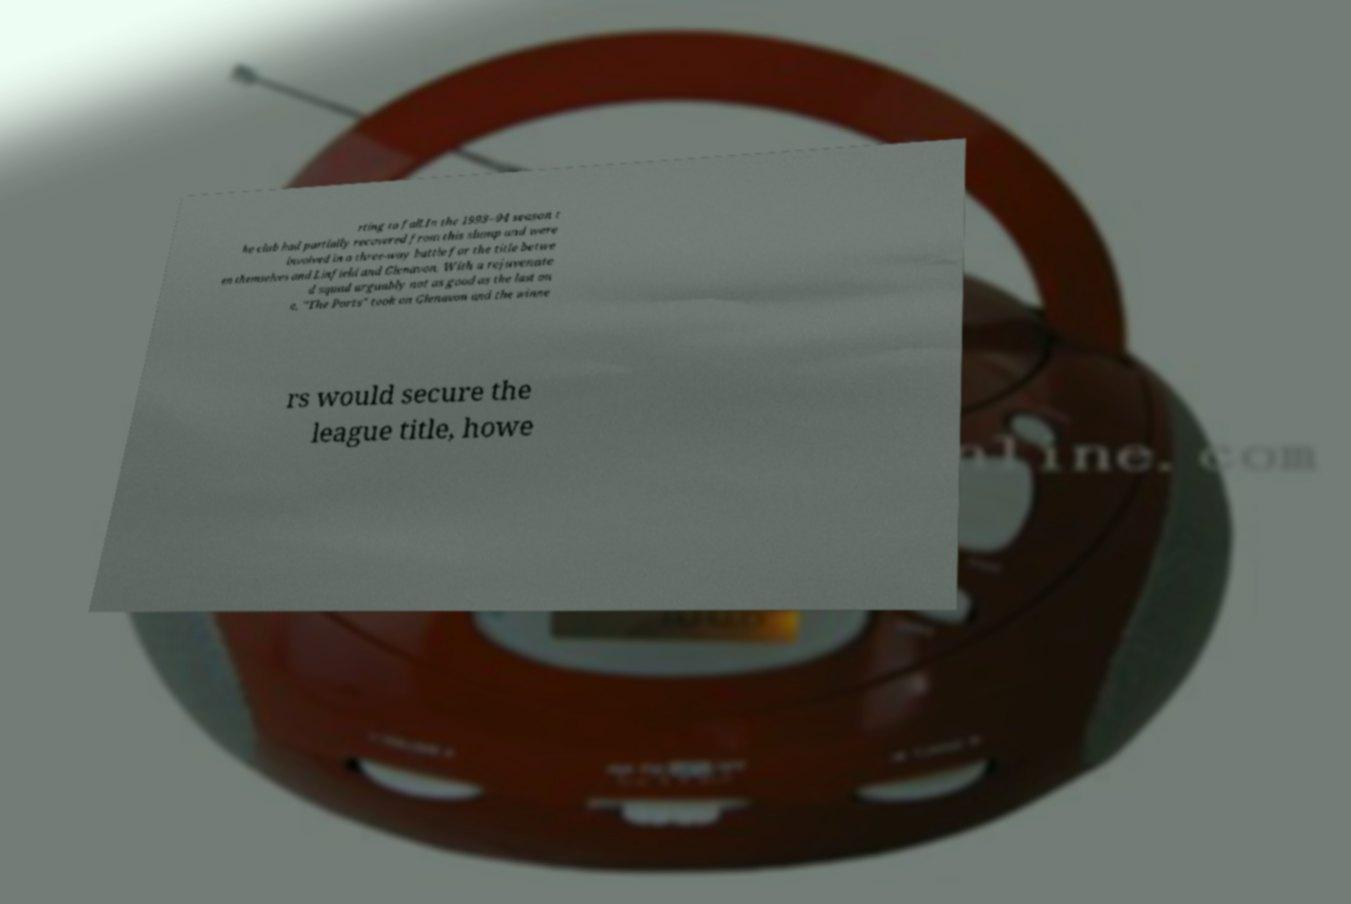Please identify and transcribe the text found in this image. rting to fall.In the 1993–94 season t he club had partially recovered from this slump and were involved in a three-way battle for the title betwe en themselves and Linfield and Glenavon. With a rejuvenate d squad arguably not as good as the last on e, "The Ports" took on Glenavon and the winne rs would secure the league title, howe 